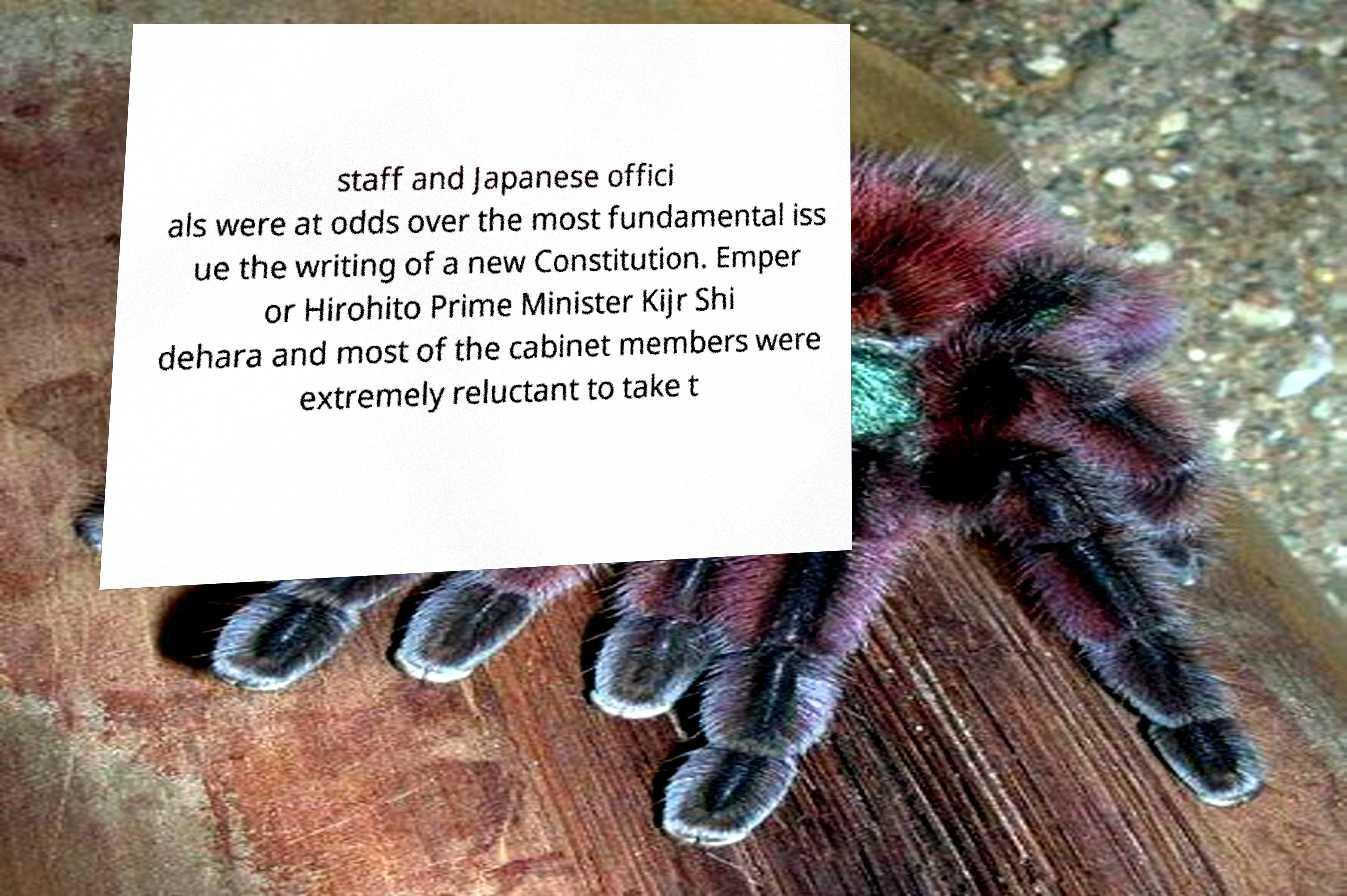Can you read and provide the text displayed in the image?This photo seems to have some interesting text. Can you extract and type it out for me? staff and Japanese offici als were at odds over the most fundamental iss ue the writing of a new Constitution. Emper or Hirohito Prime Minister Kijr Shi dehara and most of the cabinet members were extremely reluctant to take t 